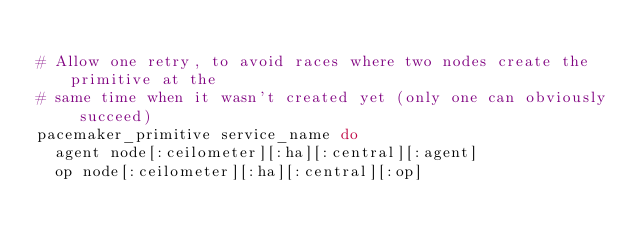<code> <loc_0><loc_0><loc_500><loc_500><_Ruby_>
# Allow one retry, to avoid races where two nodes create the primitive at the
# same time when it wasn't created yet (only one can obviously succeed)
pacemaker_primitive service_name do
  agent node[:ceilometer][:ha][:central][:agent]
  op node[:ceilometer][:ha][:central][:op]</code> 